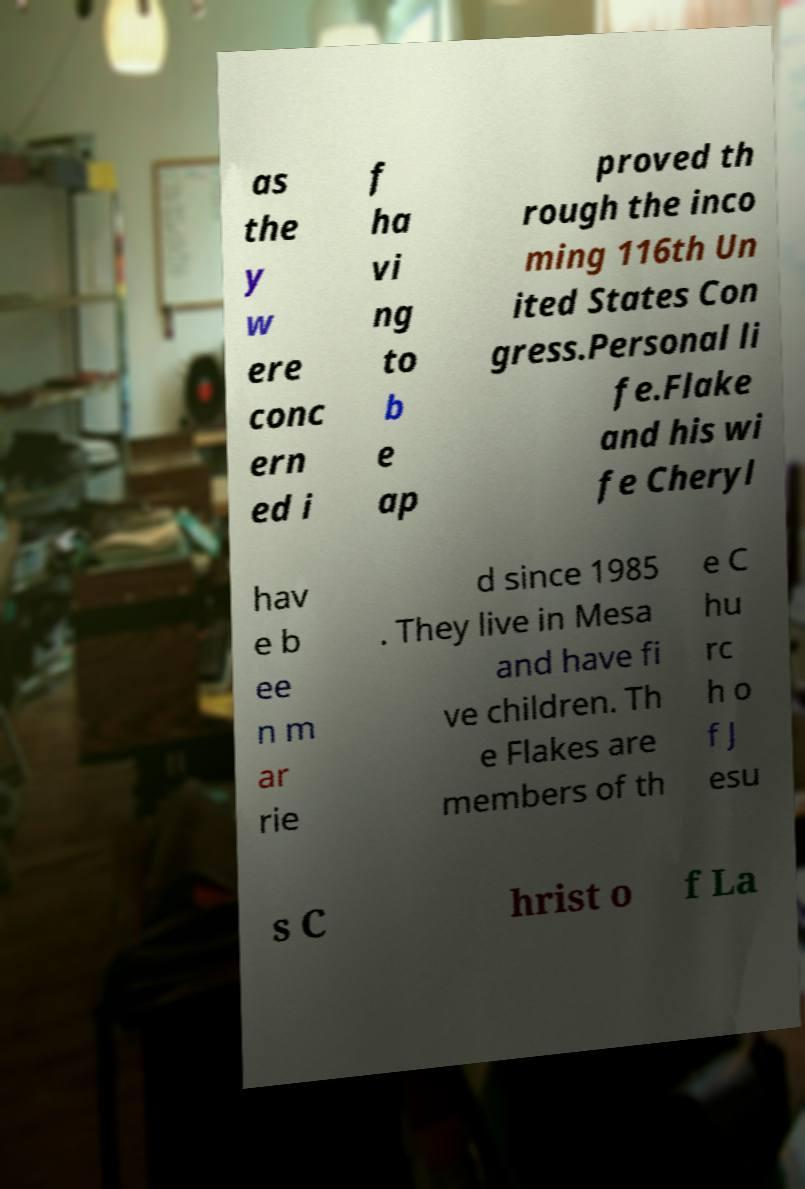For documentation purposes, I need the text within this image transcribed. Could you provide that? as the y w ere conc ern ed i f ha vi ng to b e ap proved th rough the inco ming 116th Un ited States Con gress.Personal li fe.Flake and his wi fe Cheryl hav e b ee n m ar rie d since 1985 . They live in Mesa and have fi ve children. Th e Flakes are members of th e C hu rc h o f J esu s C hrist o f La 